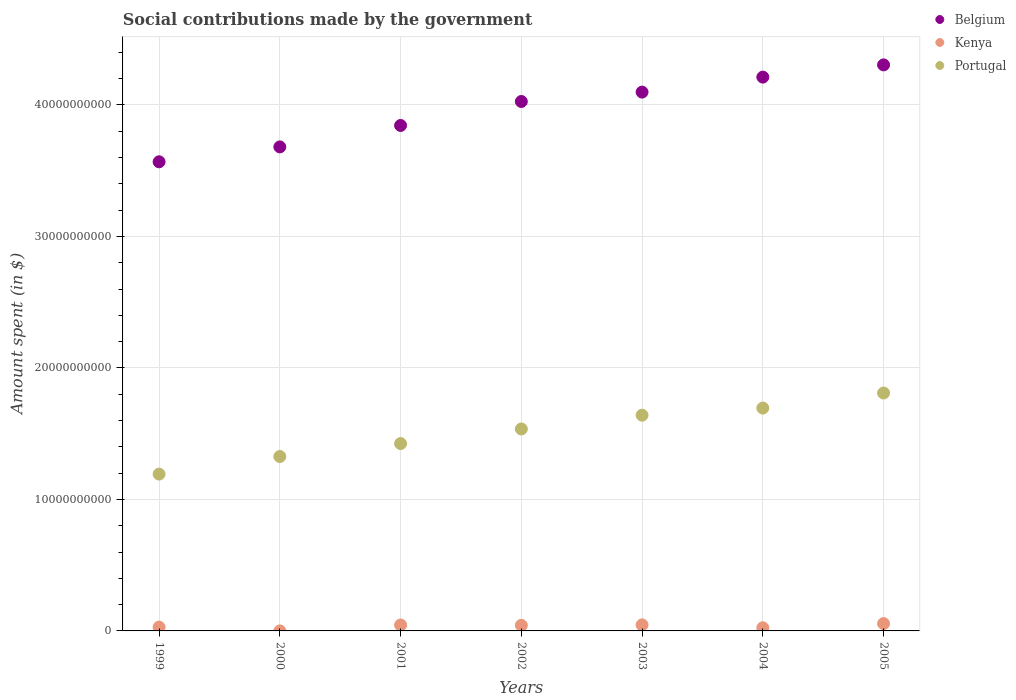How many different coloured dotlines are there?
Provide a succinct answer. 3. Is the number of dotlines equal to the number of legend labels?
Offer a terse response. Yes. What is the amount spent on social contributions in Portugal in 2001?
Make the answer very short. 1.42e+1. Across all years, what is the maximum amount spent on social contributions in Portugal?
Provide a succinct answer. 1.81e+1. Across all years, what is the minimum amount spent on social contributions in Belgium?
Your answer should be very brief. 3.57e+1. In which year was the amount spent on social contributions in Kenya maximum?
Ensure brevity in your answer.  2005. In which year was the amount spent on social contributions in Belgium minimum?
Ensure brevity in your answer.  1999. What is the total amount spent on social contributions in Belgium in the graph?
Keep it short and to the point. 2.77e+11. What is the difference between the amount spent on social contributions in Belgium in 1999 and that in 2004?
Offer a very short reply. -6.44e+09. What is the difference between the amount spent on social contributions in Kenya in 2004 and the amount spent on social contributions in Portugal in 2001?
Provide a succinct answer. -1.40e+1. What is the average amount spent on social contributions in Portugal per year?
Make the answer very short. 1.52e+1. In the year 2001, what is the difference between the amount spent on social contributions in Kenya and amount spent on social contributions in Portugal?
Make the answer very short. -1.38e+1. In how many years, is the amount spent on social contributions in Belgium greater than 24000000000 $?
Keep it short and to the point. 7. What is the ratio of the amount spent on social contributions in Kenya in 2000 to that in 2005?
Provide a succinct answer. 0. Is the amount spent on social contributions in Portugal in 1999 less than that in 2003?
Your answer should be very brief. Yes. Is the difference between the amount spent on social contributions in Kenya in 2001 and 2003 greater than the difference between the amount spent on social contributions in Portugal in 2001 and 2003?
Your answer should be very brief. Yes. What is the difference between the highest and the second highest amount spent on social contributions in Portugal?
Offer a terse response. 1.15e+09. What is the difference between the highest and the lowest amount spent on social contributions in Kenya?
Your answer should be very brief. 5.56e+08. Is it the case that in every year, the sum of the amount spent on social contributions in Kenya and amount spent on social contributions in Belgium  is greater than the amount spent on social contributions in Portugal?
Your answer should be compact. Yes. Is the amount spent on social contributions in Kenya strictly less than the amount spent on social contributions in Belgium over the years?
Offer a terse response. Yes. How many dotlines are there?
Provide a succinct answer. 3. What is the difference between two consecutive major ticks on the Y-axis?
Ensure brevity in your answer.  1.00e+1. Does the graph contain grids?
Your answer should be very brief. Yes. How are the legend labels stacked?
Offer a terse response. Vertical. What is the title of the graph?
Give a very brief answer. Social contributions made by the government. Does "Monaco" appear as one of the legend labels in the graph?
Offer a terse response. No. What is the label or title of the X-axis?
Offer a very short reply. Years. What is the label or title of the Y-axis?
Your response must be concise. Amount spent (in $). What is the Amount spent (in $) in Belgium in 1999?
Offer a very short reply. 3.57e+1. What is the Amount spent (in $) in Kenya in 1999?
Give a very brief answer. 2.91e+08. What is the Amount spent (in $) in Portugal in 1999?
Your response must be concise. 1.19e+1. What is the Amount spent (in $) of Belgium in 2000?
Offer a very short reply. 3.68e+1. What is the Amount spent (in $) in Kenya in 2000?
Give a very brief answer. 2.00e+06. What is the Amount spent (in $) of Portugal in 2000?
Provide a short and direct response. 1.33e+1. What is the Amount spent (in $) of Belgium in 2001?
Offer a terse response. 3.84e+1. What is the Amount spent (in $) in Kenya in 2001?
Offer a very short reply. 4.51e+08. What is the Amount spent (in $) of Portugal in 2001?
Offer a terse response. 1.42e+1. What is the Amount spent (in $) of Belgium in 2002?
Offer a terse response. 4.03e+1. What is the Amount spent (in $) of Kenya in 2002?
Provide a succinct answer. 4.24e+08. What is the Amount spent (in $) of Portugal in 2002?
Make the answer very short. 1.54e+1. What is the Amount spent (in $) of Belgium in 2003?
Your answer should be compact. 4.10e+1. What is the Amount spent (in $) in Kenya in 2003?
Offer a terse response. 4.60e+08. What is the Amount spent (in $) in Portugal in 2003?
Ensure brevity in your answer.  1.64e+1. What is the Amount spent (in $) of Belgium in 2004?
Keep it short and to the point. 4.21e+1. What is the Amount spent (in $) in Kenya in 2004?
Your answer should be compact. 2.39e+08. What is the Amount spent (in $) of Portugal in 2004?
Offer a terse response. 1.69e+1. What is the Amount spent (in $) in Belgium in 2005?
Your answer should be very brief. 4.30e+1. What is the Amount spent (in $) in Kenya in 2005?
Ensure brevity in your answer.  5.58e+08. What is the Amount spent (in $) in Portugal in 2005?
Give a very brief answer. 1.81e+1. Across all years, what is the maximum Amount spent (in $) of Belgium?
Your response must be concise. 4.30e+1. Across all years, what is the maximum Amount spent (in $) in Kenya?
Your answer should be very brief. 5.58e+08. Across all years, what is the maximum Amount spent (in $) of Portugal?
Give a very brief answer. 1.81e+1. Across all years, what is the minimum Amount spent (in $) of Belgium?
Ensure brevity in your answer.  3.57e+1. Across all years, what is the minimum Amount spent (in $) in Portugal?
Give a very brief answer. 1.19e+1. What is the total Amount spent (in $) of Belgium in the graph?
Make the answer very short. 2.77e+11. What is the total Amount spent (in $) of Kenya in the graph?
Provide a succinct answer. 2.42e+09. What is the total Amount spent (in $) of Portugal in the graph?
Your answer should be compact. 1.06e+11. What is the difference between the Amount spent (in $) of Belgium in 1999 and that in 2000?
Offer a terse response. -1.13e+09. What is the difference between the Amount spent (in $) in Kenya in 1999 and that in 2000?
Your response must be concise. 2.89e+08. What is the difference between the Amount spent (in $) of Portugal in 1999 and that in 2000?
Ensure brevity in your answer.  -1.34e+09. What is the difference between the Amount spent (in $) of Belgium in 1999 and that in 2001?
Keep it short and to the point. -2.76e+09. What is the difference between the Amount spent (in $) of Kenya in 1999 and that in 2001?
Give a very brief answer. -1.60e+08. What is the difference between the Amount spent (in $) in Portugal in 1999 and that in 2001?
Make the answer very short. -2.32e+09. What is the difference between the Amount spent (in $) in Belgium in 1999 and that in 2002?
Provide a succinct answer. -4.59e+09. What is the difference between the Amount spent (in $) of Kenya in 1999 and that in 2002?
Give a very brief answer. -1.33e+08. What is the difference between the Amount spent (in $) in Portugal in 1999 and that in 2002?
Your response must be concise. -3.43e+09. What is the difference between the Amount spent (in $) of Belgium in 1999 and that in 2003?
Provide a short and direct response. -5.30e+09. What is the difference between the Amount spent (in $) in Kenya in 1999 and that in 2003?
Make the answer very short. -1.69e+08. What is the difference between the Amount spent (in $) of Portugal in 1999 and that in 2003?
Your answer should be compact. -4.48e+09. What is the difference between the Amount spent (in $) in Belgium in 1999 and that in 2004?
Your answer should be very brief. -6.44e+09. What is the difference between the Amount spent (in $) of Kenya in 1999 and that in 2004?
Keep it short and to the point. 5.15e+07. What is the difference between the Amount spent (in $) of Portugal in 1999 and that in 2004?
Offer a very short reply. -5.02e+09. What is the difference between the Amount spent (in $) in Belgium in 1999 and that in 2005?
Keep it short and to the point. -7.37e+09. What is the difference between the Amount spent (in $) in Kenya in 1999 and that in 2005?
Make the answer very short. -2.67e+08. What is the difference between the Amount spent (in $) of Portugal in 1999 and that in 2005?
Keep it short and to the point. -6.17e+09. What is the difference between the Amount spent (in $) of Belgium in 2000 and that in 2001?
Your response must be concise. -1.63e+09. What is the difference between the Amount spent (in $) in Kenya in 2000 and that in 2001?
Make the answer very short. -4.49e+08. What is the difference between the Amount spent (in $) in Portugal in 2000 and that in 2001?
Provide a succinct answer. -9.82e+08. What is the difference between the Amount spent (in $) of Belgium in 2000 and that in 2002?
Offer a very short reply. -3.45e+09. What is the difference between the Amount spent (in $) of Kenya in 2000 and that in 2002?
Your answer should be compact. -4.22e+08. What is the difference between the Amount spent (in $) of Portugal in 2000 and that in 2002?
Offer a very short reply. -2.09e+09. What is the difference between the Amount spent (in $) of Belgium in 2000 and that in 2003?
Provide a succinct answer. -4.17e+09. What is the difference between the Amount spent (in $) of Kenya in 2000 and that in 2003?
Offer a very short reply. -4.58e+08. What is the difference between the Amount spent (in $) in Portugal in 2000 and that in 2003?
Ensure brevity in your answer.  -3.14e+09. What is the difference between the Amount spent (in $) of Belgium in 2000 and that in 2004?
Provide a succinct answer. -5.31e+09. What is the difference between the Amount spent (in $) of Kenya in 2000 and that in 2004?
Your answer should be very brief. -2.37e+08. What is the difference between the Amount spent (in $) of Portugal in 2000 and that in 2004?
Offer a terse response. -3.68e+09. What is the difference between the Amount spent (in $) in Belgium in 2000 and that in 2005?
Your response must be concise. -6.24e+09. What is the difference between the Amount spent (in $) in Kenya in 2000 and that in 2005?
Your answer should be compact. -5.56e+08. What is the difference between the Amount spent (in $) in Portugal in 2000 and that in 2005?
Give a very brief answer. -4.83e+09. What is the difference between the Amount spent (in $) of Belgium in 2001 and that in 2002?
Your answer should be compact. -1.82e+09. What is the difference between the Amount spent (in $) of Kenya in 2001 and that in 2002?
Your answer should be very brief. 2.73e+07. What is the difference between the Amount spent (in $) in Portugal in 2001 and that in 2002?
Provide a short and direct response. -1.11e+09. What is the difference between the Amount spent (in $) of Belgium in 2001 and that in 2003?
Your answer should be very brief. -2.54e+09. What is the difference between the Amount spent (in $) in Kenya in 2001 and that in 2003?
Your response must be concise. -8.90e+06. What is the difference between the Amount spent (in $) in Portugal in 2001 and that in 2003?
Your answer should be compact. -2.16e+09. What is the difference between the Amount spent (in $) in Belgium in 2001 and that in 2004?
Keep it short and to the point. -3.68e+09. What is the difference between the Amount spent (in $) of Kenya in 2001 and that in 2004?
Offer a very short reply. 2.12e+08. What is the difference between the Amount spent (in $) of Portugal in 2001 and that in 2004?
Offer a very short reply. -2.70e+09. What is the difference between the Amount spent (in $) in Belgium in 2001 and that in 2005?
Offer a terse response. -4.61e+09. What is the difference between the Amount spent (in $) of Kenya in 2001 and that in 2005?
Give a very brief answer. -1.07e+08. What is the difference between the Amount spent (in $) in Portugal in 2001 and that in 2005?
Keep it short and to the point. -3.85e+09. What is the difference between the Amount spent (in $) of Belgium in 2002 and that in 2003?
Ensure brevity in your answer.  -7.14e+08. What is the difference between the Amount spent (in $) in Kenya in 2002 and that in 2003?
Keep it short and to the point. -3.62e+07. What is the difference between the Amount spent (in $) of Portugal in 2002 and that in 2003?
Your answer should be compact. -1.05e+09. What is the difference between the Amount spent (in $) in Belgium in 2002 and that in 2004?
Your answer should be compact. -1.85e+09. What is the difference between the Amount spent (in $) of Kenya in 2002 and that in 2004?
Give a very brief answer. 1.85e+08. What is the difference between the Amount spent (in $) of Portugal in 2002 and that in 2004?
Your answer should be very brief. -1.59e+09. What is the difference between the Amount spent (in $) in Belgium in 2002 and that in 2005?
Offer a very short reply. -2.78e+09. What is the difference between the Amount spent (in $) in Kenya in 2002 and that in 2005?
Offer a terse response. -1.34e+08. What is the difference between the Amount spent (in $) of Portugal in 2002 and that in 2005?
Keep it short and to the point. -2.74e+09. What is the difference between the Amount spent (in $) in Belgium in 2003 and that in 2004?
Offer a very short reply. -1.14e+09. What is the difference between the Amount spent (in $) in Kenya in 2003 and that in 2004?
Offer a very short reply. 2.21e+08. What is the difference between the Amount spent (in $) in Portugal in 2003 and that in 2004?
Give a very brief answer. -5.42e+08. What is the difference between the Amount spent (in $) in Belgium in 2003 and that in 2005?
Give a very brief answer. -2.07e+09. What is the difference between the Amount spent (in $) of Kenya in 2003 and that in 2005?
Ensure brevity in your answer.  -9.81e+07. What is the difference between the Amount spent (in $) of Portugal in 2003 and that in 2005?
Offer a terse response. -1.69e+09. What is the difference between the Amount spent (in $) of Belgium in 2004 and that in 2005?
Offer a very short reply. -9.31e+08. What is the difference between the Amount spent (in $) of Kenya in 2004 and that in 2005?
Offer a terse response. -3.19e+08. What is the difference between the Amount spent (in $) of Portugal in 2004 and that in 2005?
Your response must be concise. -1.15e+09. What is the difference between the Amount spent (in $) of Belgium in 1999 and the Amount spent (in $) of Kenya in 2000?
Your response must be concise. 3.57e+1. What is the difference between the Amount spent (in $) in Belgium in 1999 and the Amount spent (in $) in Portugal in 2000?
Provide a short and direct response. 2.24e+1. What is the difference between the Amount spent (in $) of Kenya in 1999 and the Amount spent (in $) of Portugal in 2000?
Provide a short and direct response. -1.30e+1. What is the difference between the Amount spent (in $) in Belgium in 1999 and the Amount spent (in $) in Kenya in 2001?
Give a very brief answer. 3.52e+1. What is the difference between the Amount spent (in $) of Belgium in 1999 and the Amount spent (in $) of Portugal in 2001?
Provide a succinct answer. 2.14e+1. What is the difference between the Amount spent (in $) in Kenya in 1999 and the Amount spent (in $) in Portugal in 2001?
Provide a short and direct response. -1.40e+1. What is the difference between the Amount spent (in $) in Belgium in 1999 and the Amount spent (in $) in Kenya in 2002?
Your answer should be compact. 3.53e+1. What is the difference between the Amount spent (in $) in Belgium in 1999 and the Amount spent (in $) in Portugal in 2002?
Ensure brevity in your answer.  2.03e+1. What is the difference between the Amount spent (in $) in Kenya in 1999 and the Amount spent (in $) in Portugal in 2002?
Offer a terse response. -1.51e+1. What is the difference between the Amount spent (in $) in Belgium in 1999 and the Amount spent (in $) in Kenya in 2003?
Ensure brevity in your answer.  3.52e+1. What is the difference between the Amount spent (in $) of Belgium in 1999 and the Amount spent (in $) of Portugal in 2003?
Your response must be concise. 1.93e+1. What is the difference between the Amount spent (in $) in Kenya in 1999 and the Amount spent (in $) in Portugal in 2003?
Make the answer very short. -1.61e+1. What is the difference between the Amount spent (in $) of Belgium in 1999 and the Amount spent (in $) of Kenya in 2004?
Keep it short and to the point. 3.54e+1. What is the difference between the Amount spent (in $) of Belgium in 1999 and the Amount spent (in $) of Portugal in 2004?
Give a very brief answer. 1.87e+1. What is the difference between the Amount spent (in $) in Kenya in 1999 and the Amount spent (in $) in Portugal in 2004?
Ensure brevity in your answer.  -1.67e+1. What is the difference between the Amount spent (in $) of Belgium in 1999 and the Amount spent (in $) of Kenya in 2005?
Keep it short and to the point. 3.51e+1. What is the difference between the Amount spent (in $) in Belgium in 1999 and the Amount spent (in $) in Portugal in 2005?
Offer a terse response. 1.76e+1. What is the difference between the Amount spent (in $) in Kenya in 1999 and the Amount spent (in $) in Portugal in 2005?
Your answer should be very brief. -1.78e+1. What is the difference between the Amount spent (in $) of Belgium in 2000 and the Amount spent (in $) of Kenya in 2001?
Make the answer very short. 3.64e+1. What is the difference between the Amount spent (in $) of Belgium in 2000 and the Amount spent (in $) of Portugal in 2001?
Offer a very short reply. 2.26e+1. What is the difference between the Amount spent (in $) of Kenya in 2000 and the Amount spent (in $) of Portugal in 2001?
Provide a short and direct response. -1.42e+1. What is the difference between the Amount spent (in $) in Belgium in 2000 and the Amount spent (in $) in Kenya in 2002?
Provide a short and direct response. 3.64e+1. What is the difference between the Amount spent (in $) of Belgium in 2000 and the Amount spent (in $) of Portugal in 2002?
Ensure brevity in your answer.  2.15e+1. What is the difference between the Amount spent (in $) of Kenya in 2000 and the Amount spent (in $) of Portugal in 2002?
Provide a short and direct response. -1.54e+1. What is the difference between the Amount spent (in $) in Belgium in 2000 and the Amount spent (in $) in Kenya in 2003?
Provide a short and direct response. 3.64e+1. What is the difference between the Amount spent (in $) in Belgium in 2000 and the Amount spent (in $) in Portugal in 2003?
Keep it short and to the point. 2.04e+1. What is the difference between the Amount spent (in $) of Kenya in 2000 and the Amount spent (in $) of Portugal in 2003?
Ensure brevity in your answer.  -1.64e+1. What is the difference between the Amount spent (in $) of Belgium in 2000 and the Amount spent (in $) of Kenya in 2004?
Your response must be concise. 3.66e+1. What is the difference between the Amount spent (in $) of Belgium in 2000 and the Amount spent (in $) of Portugal in 2004?
Give a very brief answer. 1.99e+1. What is the difference between the Amount spent (in $) in Kenya in 2000 and the Amount spent (in $) in Portugal in 2004?
Your response must be concise. -1.69e+1. What is the difference between the Amount spent (in $) of Belgium in 2000 and the Amount spent (in $) of Kenya in 2005?
Offer a terse response. 3.63e+1. What is the difference between the Amount spent (in $) in Belgium in 2000 and the Amount spent (in $) in Portugal in 2005?
Your response must be concise. 1.87e+1. What is the difference between the Amount spent (in $) in Kenya in 2000 and the Amount spent (in $) in Portugal in 2005?
Give a very brief answer. -1.81e+1. What is the difference between the Amount spent (in $) in Belgium in 2001 and the Amount spent (in $) in Kenya in 2002?
Provide a succinct answer. 3.80e+1. What is the difference between the Amount spent (in $) of Belgium in 2001 and the Amount spent (in $) of Portugal in 2002?
Keep it short and to the point. 2.31e+1. What is the difference between the Amount spent (in $) in Kenya in 2001 and the Amount spent (in $) in Portugal in 2002?
Offer a terse response. -1.49e+1. What is the difference between the Amount spent (in $) of Belgium in 2001 and the Amount spent (in $) of Kenya in 2003?
Keep it short and to the point. 3.80e+1. What is the difference between the Amount spent (in $) in Belgium in 2001 and the Amount spent (in $) in Portugal in 2003?
Your response must be concise. 2.20e+1. What is the difference between the Amount spent (in $) in Kenya in 2001 and the Amount spent (in $) in Portugal in 2003?
Give a very brief answer. -1.60e+1. What is the difference between the Amount spent (in $) of Belgium in 2001 and the Amount spent (in $) of Kenya in 2004?
Your response must be concise. 3.82e+1. What is the difference between the Amount spent (in $) of Belgium in 2001 and the Amount spent (in $) of Portugal in 2004?
Ensure brevity in your answer.  2.15e+1. What is the difference between the Amount spent (in $) in Kenya in 2001 and the Amount spent (in $) in Portugal in 2004?
Make the answer very short. -1.65e+1. What is the difference between the Amount spent (in $) in Belgium in 2001 and the Amount spent (in $) in Kenya in 2005?
Ensure brevity in your answer.  3.79e+1. What is the difference between the Amount spent (in $) in Belgium in 2001 and the Amount spent (in $) in Portugal in 2005?
Your answer should be compact. 2.03e+1. What is the difference between the Amount spent (in $) of Kenya in 2001 and the Amount spent (in $) of Portugal in 2005?
Give a very brief answer. -1.76e+1. What is the difference between the Amount spent (in $) in Belgium in 2002 and the Amount spent (in $) in Kenya in 2003?
Offer a terse response. 3.98e+1. What is the difference between the Amount spent (in $) of Belgium in 2002 and the Amount spent (in $) of Portugal in 2003?
Offer a very short reply. 2.39e+1. What is the difference between the Amount spent (in $) of Kenya in 2002 and the Amount spent (in $) of Portugal in 2003?
Your answer should be compact. -1.60e+1. What is the difference between the Amount spent (in $) in Belgium in 2002 and the Amount spent (in $) in Kenya in 2004?
Offer a terse response. 4.00e+1. What is the difference between the Amount spent (in $) of Belgium in 2002 and the Amount spent (in $) of Portugal in 2004?
Offer a terse response. 2.33e+1. What is the difference between the Amount spent (in $) of Kenya in 2002 and the Amount spent (in $) of Portugal in 2004?
Your answer should be very brief. -1.65e+1. What is the difference between the Amount spent (in $) in Belgium in 2002 and the Amount spent (in $) in Kenya in 2005?
Give a very brief answer. 3.97e+1. What is the difference between the Amount spent (in $) in Belgium in 2002 and the Amount spent (in $) in Portugal in 2005?
Ensure brevity in your answer.  2.22e+1. What is the difference between the Amount spent (in $) of Kenya in 2002 and the Amount spent (in $) of Portugal in 2005?
Offer a terse response. -1.77e+1. What is the difference between the Amount spent (in $) in Belgium in 2003 and the Amount spent (in $) in Kenya in 2004?
Your response must be concise. 4.07e+1. What is the difference between the Amount spent (in $) of Belgium in 2003 and the Amount spent (in $) of Portugal in 2004?
Offer a very short reply. 2.40e+1. What is the difference between the Amount spent (in $) of Kenya in 2003 and the Amount spent (in $) of Portugal in 2004?
Your answer should be compact. -1.65e+1. What is the difference between the Amount spent (in $) in Belgium in 2003 and the Amount spent (in $) in Kenya in 2005?
Keep it short and to the point. 4.04e+1. What is the difference between the Amount spent (in $) of Belgium in 2003 and the Amount spent (in $) of Portugal in 2005?
Offer a very short reply. 2.29e+1. What is the difference between the Amount spent (in $) in Kenya in 2003 and the Amount spent (in $) in Portugal in 2005?
Give a very brief answer. -1.76e+1. What is the difference between the Amount spent (in $) of Belgium in 2004 and the Amount spent (in $) of Kenya in 2005?
Your response must be concise. 4.16e+1. What is the difference between the Amount spent (in $) in Belgium in 2004 and the Amount spent (in $) in Portugal in 2005?
Your response must be concise. 2.40e+1. What is the difference between the Amount spent (in $) in Kenya in 2004 and the Amount spent (in $) in Portugal in 2005?
Your answer should be compact. -1.79e+1. What is the average Amount spent (in $) in Belgium per year?
Provide a short and direct response. 3.96e+1. What is the average Amount spent (in $) of Kenya per year?
Your answer should be very brief. 3.46e+08. What is the average Amount spent (in $) of Portugal per year?
Your answer should be very brief. 1.52e+1. In the year 1999, what is the difference between the Amount spent (in $) of Belgium and Amount spent (in $) of Kenya?
Your answer should be compact. 3.54e+1. In the year 1999, what is the difference between the Amount spent (in $) of Belgium and Amount spent (in $) of Portugal?
Make the answer very short. 2.38e+1. In the year 1999, what is the difference between the Amount spent (in $) in Kenya and Amount spent (in $) in Portugal?
Your answer should be very brief. -1.16e+1. In the year 2000, what is the difference between the Amount spent (in $) of Belgium and Amount spent (in $) of Kenya?
Ensure brevity in your answer.  3.68e+1. In the year 2000, what is the difference between the Amount spent (in $) in Belgium and Amount spent (in $) in Portugal?
Keep it short and to the point. 2.35e+1. In the year 2000, what is the difference between the Amount spent (in $) in Kenya and Amount spent (in $) in Portugal?
Your answer should be compact. -1.33e+1. In the year 2001, what is the difference between the Amount spent (in $) of Belgium and Amount spent (in $) of Kenya?
Provide a short and direct response. 3.80e+1. In the year 2001, what is the difference between the Amount spent (in $) in Belgium and Amount spent (in $) in Portugal?
Offer a terse response. 2.42e+1. In the year 2001, what is the difference between the Amount spent (in $) in Kenya and Amount spent (in $) in Portugal?
Give a very brief answer. -1.38e+1. In the year 2002, what is the difference between the Amount spent (in $) in Belgium and Amount spent (in $) in Kenya?
Your answer should be compact. 3.98e+1. In the year 2002, what is the difference between the Amount spent (in $) of Belgium and Amount spent (in $) of Portugal?
Ensure brevity in your answer.  2.49e+1. In the year 2002, what is the difference between the Amount spent (in $) of Kenya and Amount spent (in $) of Portugal?
Make the answer very short. -1.49e+1. In the year 2003, what is the difference between the Amount spent (in $) of Belgium and Amount spent (in $) of Kenya?
Ensure brevity in your answer.  4.05e+1. In the year 2003, what is the difference between the Amount spent (in $) of Belgium and Amount spent (in $) of Portugal?
Offer a very short reply. 2.46e+1. In the year 2003, what is the difference between the Amount spent (in $) of Kenya and Amount spent (in $) of Portugal?
Give a very brief answer. -1.59e+1. In the year 2004, what is the difference between the Amount spent (in $) of Belgium and Amount spent (in $) of Kenya?
Make the answer very short. 4.19e+1. In the year 2004, what is the difference between the Amount spent (in $) of Belgium and Amount spent (in $) of Portugal?
Your response must be concise. 2.52e+1. In the year 2004, what is the difference between the Amount spent (in $) in Kenya and Amount spent (in $) in Portugal?
Offer a terse response. -1.67e+1. In the year 2005, what is the difference between the Amount spent (in $) in Belgium and Amount spent (in $) in Kenya?
Your answer should be compact. 4.25e+1. In the year 2005, what is the difference between the Amount spent (in $) of Belgium and Amount spent (in $) of Portugal?
Provide a succinct answer. 2.50e+1. In the year 2005, what is the difference between the Amount spent (in $) of Kenya and Amount spent (in $) of Portugal?
Make the answer very short. -1.75e+1. What is the ratio of the Amount spent (in $) of Belgium in 1999 to that in 2000?
Offer a terse response. 0.97. What is the ratio of the Amount spent (in $) in Kenya in 1999 to that in 2000?
Ensure brevity in your answer.  145.3. What is the ratio of the Amount spent (in $) of Portugal in 1999 to that in 2000?
Keep it short and to the point. 0.9. What is the ratio of the Amount spent (in $) in Belgium in 1999 to that in 2001?
Offer a very short reply. 0.93. What is the ratio of the Amount spent (in $) of Kenya in 1999 to that in 2001?
Your answer should be very brief. 0.64. What is the ratio of the Amount spent (in $) of Portugal in 1999 to that in 2001?
Your answer should be very brief. 0.84. What is the ratio of the Amount spent (in $) in Belgium in 1999 to that in 2002?
Provide a succinct answer. 0.89. What is the ratio of the Amount spent (in $) in Kenya in 1999 to that in 2002?
Offer a terse response. 0.69. What is the ratio of the Amount spent (in $) of Portugal in 1999 to that in 2002?
Keep it short and to the point. 0.78. What is the ratio of the Amount spent (in $) in Belgium in 1999 to that in 2003?
Offer a very short reply. 0.87. What is the ratio of the Amount spent (in $) in Kenya in 1999 to that in 2003?
Provide a short and direct response. 0.63. What is the ratio of the Amount spent (in $) of Portugal in 1999 to that in 2003?
Offer a very short reply. 0.73. What is the ratio of the Amount spent (in $) in Belgium in 1999 to that in 2004?
Ensure brevity in your answer.  0.85. What is the ratio of the Amount spent (in $) in Kenya in 1999 to that in 2004?
Give a very brief answer. 1.22. What is the ratio of the Amount spent (in $) in Portugal in 1999 to that in 2004?
Make the answer very short. 0.7. What is the ratio of the Amount spent (in $) of Belgium in 1999 to that in 2005?
Your answer should be compact. 0.83. What is the ratio of the Amount spent (in $) in Kenya in 1999 to that in 2005?
Offer a terse response. 0.52. What is the ratio of the Amount spent (in $) of Portugal in 1999 to that in 2005?
Give a very brief answer. 0.66. What is the ratio of the Amount spent (in $) in Belgium in 2000 to that in 2001?
Provide a succinct answer. 0.96. What is the ratio of the Amount spent (in $) in Kenya in 2000 to that in 2001?
Your answer should be very brief. 0. What is the ratio of the Amount spent (in $) in Portugal in 2000 to that in 2001?
Your response must be concise. 0.93. What is the ratio of the Amount spent (in $) of Belgium in 2000 to that in 2002?
Your answer should be very brief. 0.91. What is the ratio of the Amount spent (in $) in Kenya in 2000 to that in 2002?
Your answer should be compact. 0. What is the ratio of the Amount spent (in $) in Portugal in 2000 to that in 2002?
Offer a terse response. 0.86. What is the ratio of the Amount spent (in $) in Belgium in 2000 to that in 2003?
Make the answer very short. 0.9. What is the ratio of the Amount spent (in $) of Kenya in 2000 to that in 2003?
Make the answer very short. 0. What is the ratio of the Amount spent (in $) of Portugal in 2000 to that in 2003?
Provide a short and direct response. 0.81. What is the ratio of the Amount spent (in $) of Belgium in 2000 to that in 2004?
Ensure brevity in your answer.  0.87. What is the ratio of the Amount spent (in $) in Kenya in 2000 to that in 2004?
Your response must be concise. 0.01. What is the ratio of the Amount spent (in $) of Portugal in 2000 to that in 2004?
Your answer should be very brief. 0.78. What is the ratio of the Amount spent (in $) in Belgium in 2000 to that in 2005?
Your answer should be compact. 0.86. What is the ratio of the Amount spent (in $) of Kenya in 2000 to that in 2005?
Keep it short and to the point. 0. What is the ratio of the Amount spent (in $) of Portugal in 2000 to that in 2005?
Ensure brevity in your answer.  0.73. What is the ratio of the Amount spent (in $) in Belgium in 2001 to that in 2002?
Offer a terse response. 0.95. What is the ratio of the Amount spent (in $) in Kenya in 2001 to that in 2002?
Provide a succinct answer. 1.06. What is the ratio of the Amount spent (in $) of Portugal in 2001 to that in 2002?
Your answer should be very brief. 0.93. What is the ratio of the Amount spent (in $) of Belgium in 2001 to that in 2003?
Ensure brevity in your answer.  0.94. What is the ratio of the Amount spent (in $) in Kenya in 2001 to that in 2003?
Make the answer very short. 0.98. What is the ratio of the Amount spent (in $) of Portugal in 2001 to that in 2003?
Keep it short and to the point. 0.87. What is the ratio of the Amount spent (in $) of Belgium in 2001 to that in 2004?
Provide a succinct answer. 0.91. What is the ratio of the Amount spent (in $) in Kenya in 2001 to that in 2004?
Offer a terse response. 1.89. What is the ratio of the Amount spent (in $) in Portugal in 2001 to that in 2004?
Ensure brevity in your answer.  0.84. What is the ratio of the Amount spent (in $) of Belgium in 2001 to that in 2005?
Your response must be concise. 0.89. What is the ratio of the Amount spent (in $) in Kenya in 2001 to that in 2005?
Keep it short and to the point. 0.81. What is the ratio of the Amount spent (in $) of Portugal in 2001 to that in 2005?
Provide a short and direct response. 0.79. What is the ratio of the Amount spent (in $) of Belgium in 2002 to that in 2003?
Your response must be concise. 0.98. What is the ratio of the Amount spent (in $) in Kenya in 2002 to that in 2003?
Your response must be concise. 0.92. What is the ratio of the Amount spent (in $) of Portugal in 2002 to that in 2003?
Make the answer very short. 0.94. What is the ratio of the Amount spent (in $) in Belgium in 2002 to that in 2004?
Your answer should be compact. 0.96. What is the ratio of the Amount spent (in $) in Kenya in 2002 to that in 2004?
Your response must be concise. 1.77. What is the ratio of the Amount spent (in $) in Portugal in 2002 to that in 2004?
Provide a succinct answer. 0.91. What is the ratio of the Amount spent (in $) in Belgium in 2002 to that in 2005?
Keep it short and to the point. 0.94. What is the ratio of the Amount spent (in $) in Kenya in 2002 to that in 2005?
Make the answer very short. 0.76. What is the ratio of the Amount spent (in $) of Portugal in 2002 to that in 2005?
Offer a terse response. 0.85. What is the ratio of the Amount spent (in $) in Belgium in 2003 to that in 2004?
Offer a terse response. 0.97. What is the ratio of the Amount spent (in $) in Kenya in 2003 to that in 2004?
Give a very brief answer. 1.92. What is the ratio of the Amount spent (in $) in Portugal in 2003 to that in 2004?
Your answer should be very brief. 0.97. What is the ratio of the Amount spent (in $) in Belgium in 2003 to that in 2005?
Offer a terse response. 0.95. What is the ratio of the Amount spent (in $) of Kenya in 2003 to that in 2005?
Make the answer very short. 0.82. What is the ratio of the Amount spent (in $) in Portugal in 2003 to that in 2005?
Your response must be concise. 0.91. What is the ratio of the Amount spent (in $) in Belgium in 2004 to that in 2005?
Your response must be concise. 0.98. What is the ratio of the Amount spent (in $) of Kenya in 2004 to that in 2005?
Keep it short and to the point. 0.43. What is the ratio of the Amount spent (in $) in Portugal in 2004 to that in 2005?
Your answer should be compact. 0.94. What is the difference between the highest and the second highest Amount spent (in $) of Belgium?
Offer a very short reply. 9.31e+08. What is the difference between the highest and the second highest Amount spent (in $) in Kenya?
Your answer should be very brief. 9.81e+07. What is the difference between the highest and the second highest Amount spent (in $) in Portugal?
Make the answer very short. 1.15e+09. What is the difference between the highest and the lowest Amount spent (in $) of Belgium?
Ensure brevity in your answer.  7.37e+09. What is the difference between the highest and the lowest Amount spent (in $) in Kenya?
Your answer should be very brief. 5.56e+08. What is the difference between the highest and the lowest Amount spent (in $) in Portugal?
Your answer should be very brief. 6.17e+09. 